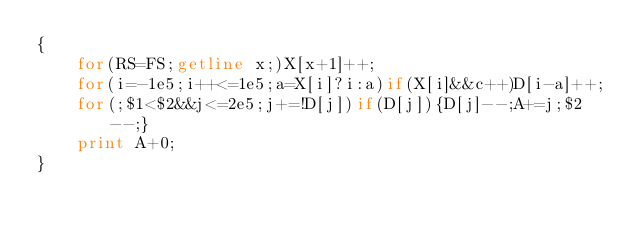Convert code to text. <code><loc_0><loc_0><loc_500><loc_500><_Awk_>{
    for(RS=FS;getline x;)X[x+1]++;
    for(i=-1e5;i++<=1e5;a=X[i]?i:a)if(X[i]&&c++)D[i-a]++;
    for(;$1<$2&&j<=2e5;j+=!D[j])if(D[j]){D[j]--;A+=j;$2--;}
    print A+0;
}</code> 